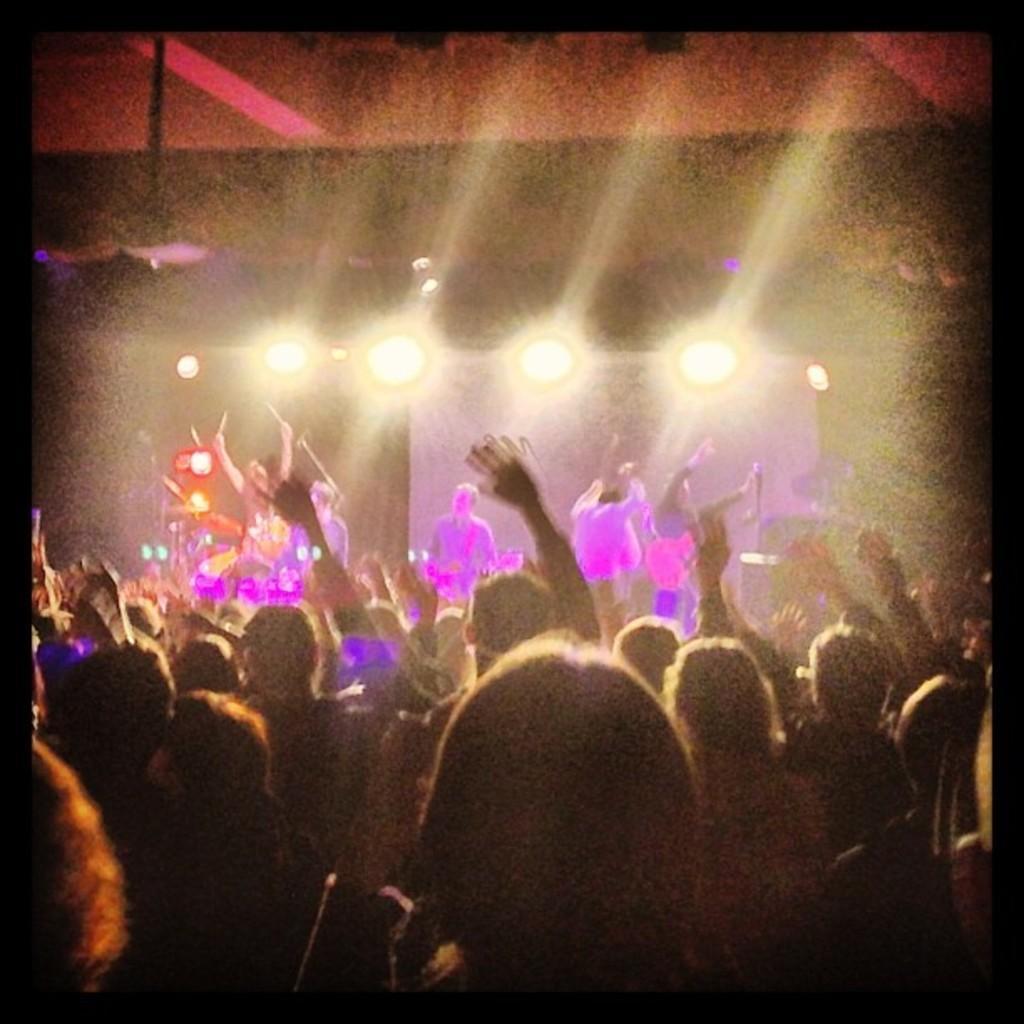How would you summarize this image in a sentence or two? In this image there are few people playing musical instruments and few are standing. Lights are visible in this image and the image has borders. 